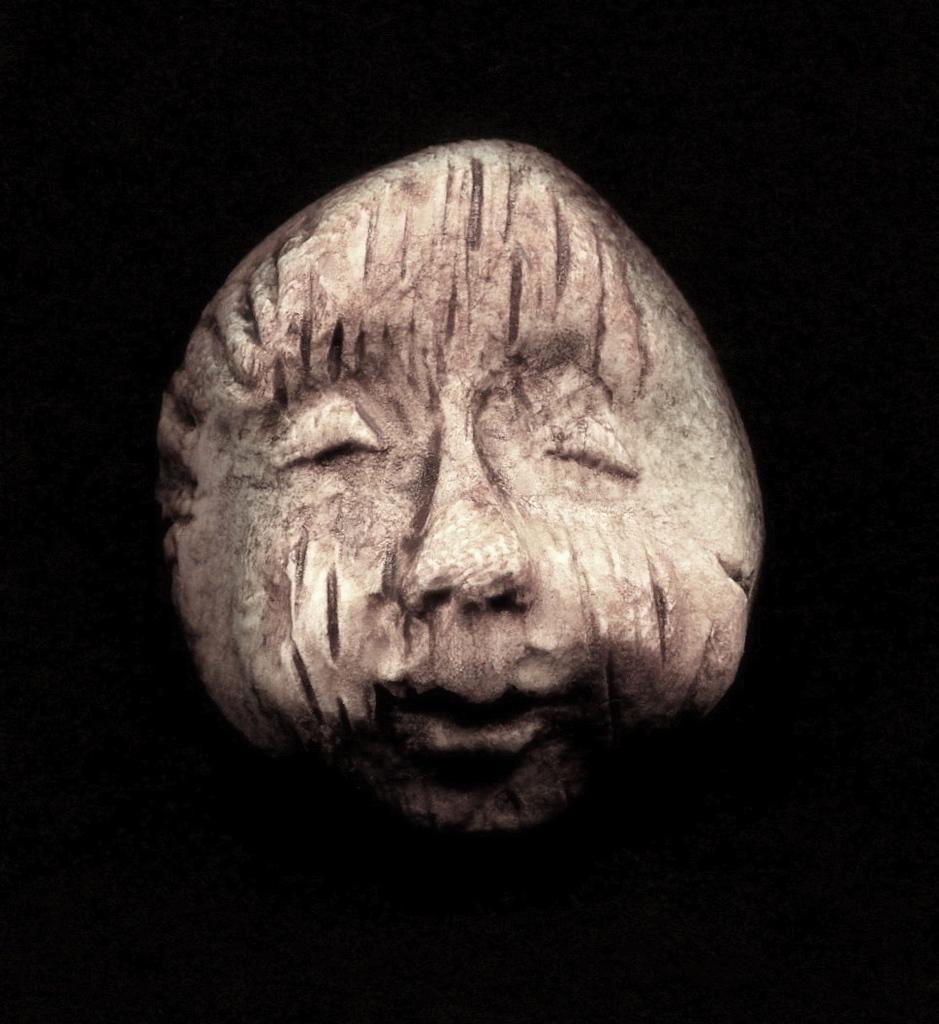Could you give a brief overview of what you see in this image? In this image there is a rock and we can see carving on it. 